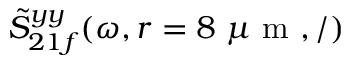Convert formula to latex. <formula><loc_0><loc_0><loc_500><loc_500>\tilde { S } _ { 2 1 f } ^ { y y } ( \omega , r = 8 \mu m , / )</formula> 